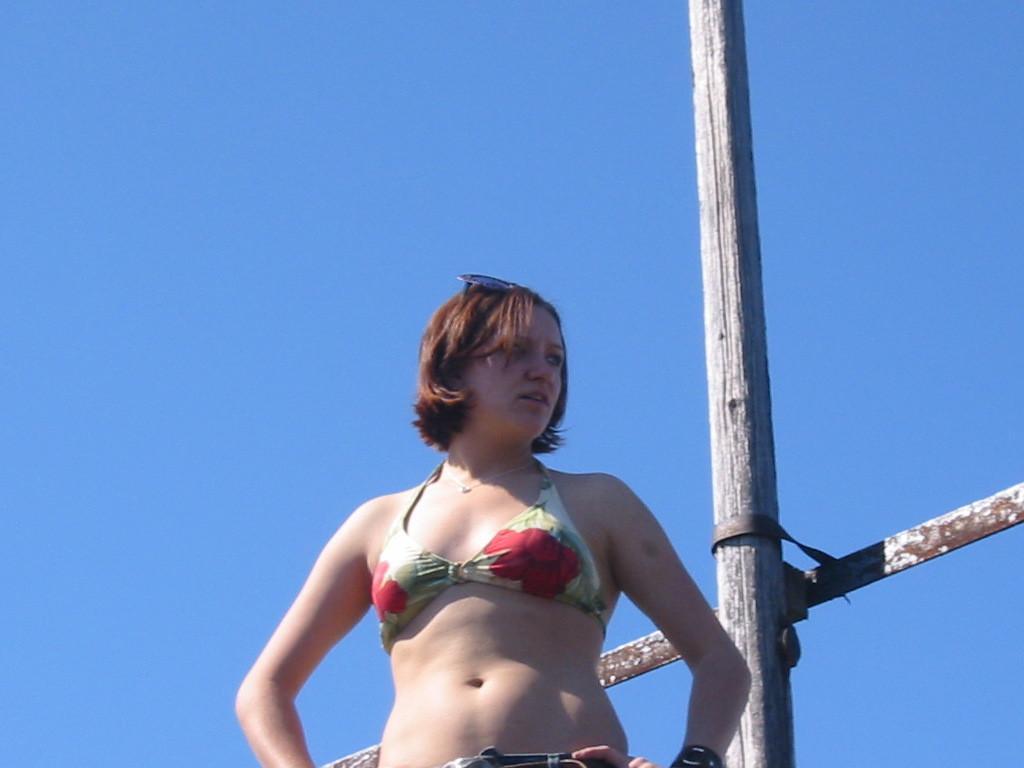Describe this image in one or two sentences. Here is the woman standing. This looks like a wooden pole. Here is the sky, which is blue in color. 